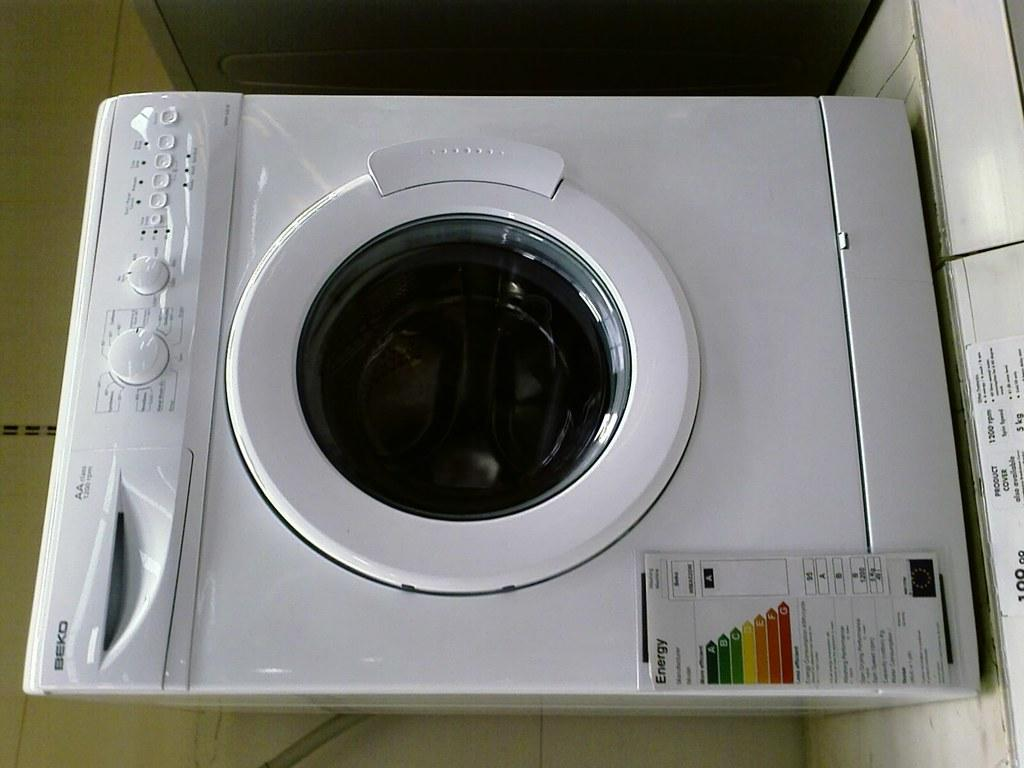What appliance can be seen in the image? There is a washing machine in the image. What is the primary function of the appliance in the image? The primary function of the washing machine is to clean clothes. Can you describe the appearance of the washing machine in the image? The washing machine appears to be a standard, household appliance. What type of smile is the washing machine displaying in the image? Washing machines do not have the ability to display emotions or smiles, as they are inanimate objects. 